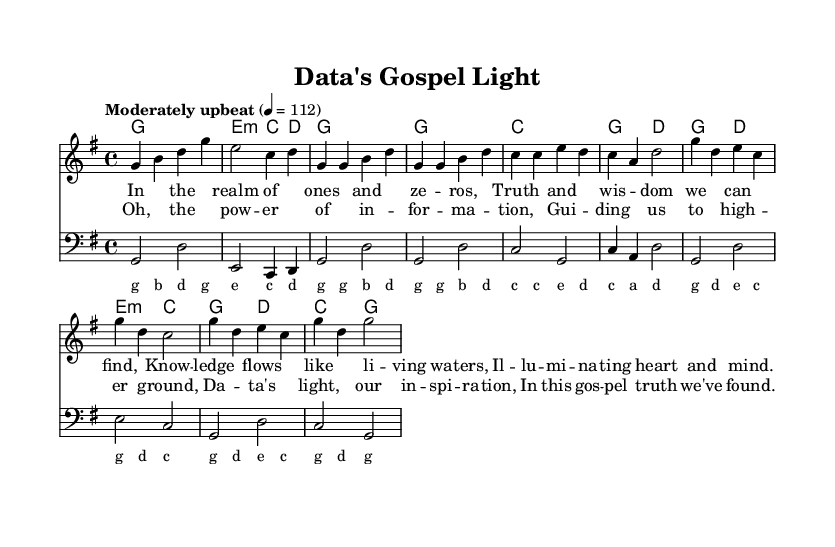What is the key signature of this music? The key signature is G major, which has one sharp (F#).
Answer: G major What is the time signature of this piece? The time signature is 4/4, indicating four beats per measure.
Answer: 4/4 What is the tempo marking for the piece? The tempo marking is "Moderately upbeat," with a quarter note equal to 112 beats per minute.
Answer: Moderately upbeat How many measures are there in the chorus section? The chorus contains four measures, as indicated in the section structure of the sheet music.
Answer: Four What is the primary theme expressed in the lyrics? The theme centers on the "power of information" and "guidance" through knowledge and truth.
Answer: Power of information Which musical section contains the lyric "In this gospel truth we've found"? This lyric is found in the chorus section, highlighting the conclusion and emphasis of the message.
Answer: Chorus What is the chord progression for the verse? The chord progression for the verse follows G, G, C, G2, D.
Answer: G, G, C, G2, D 